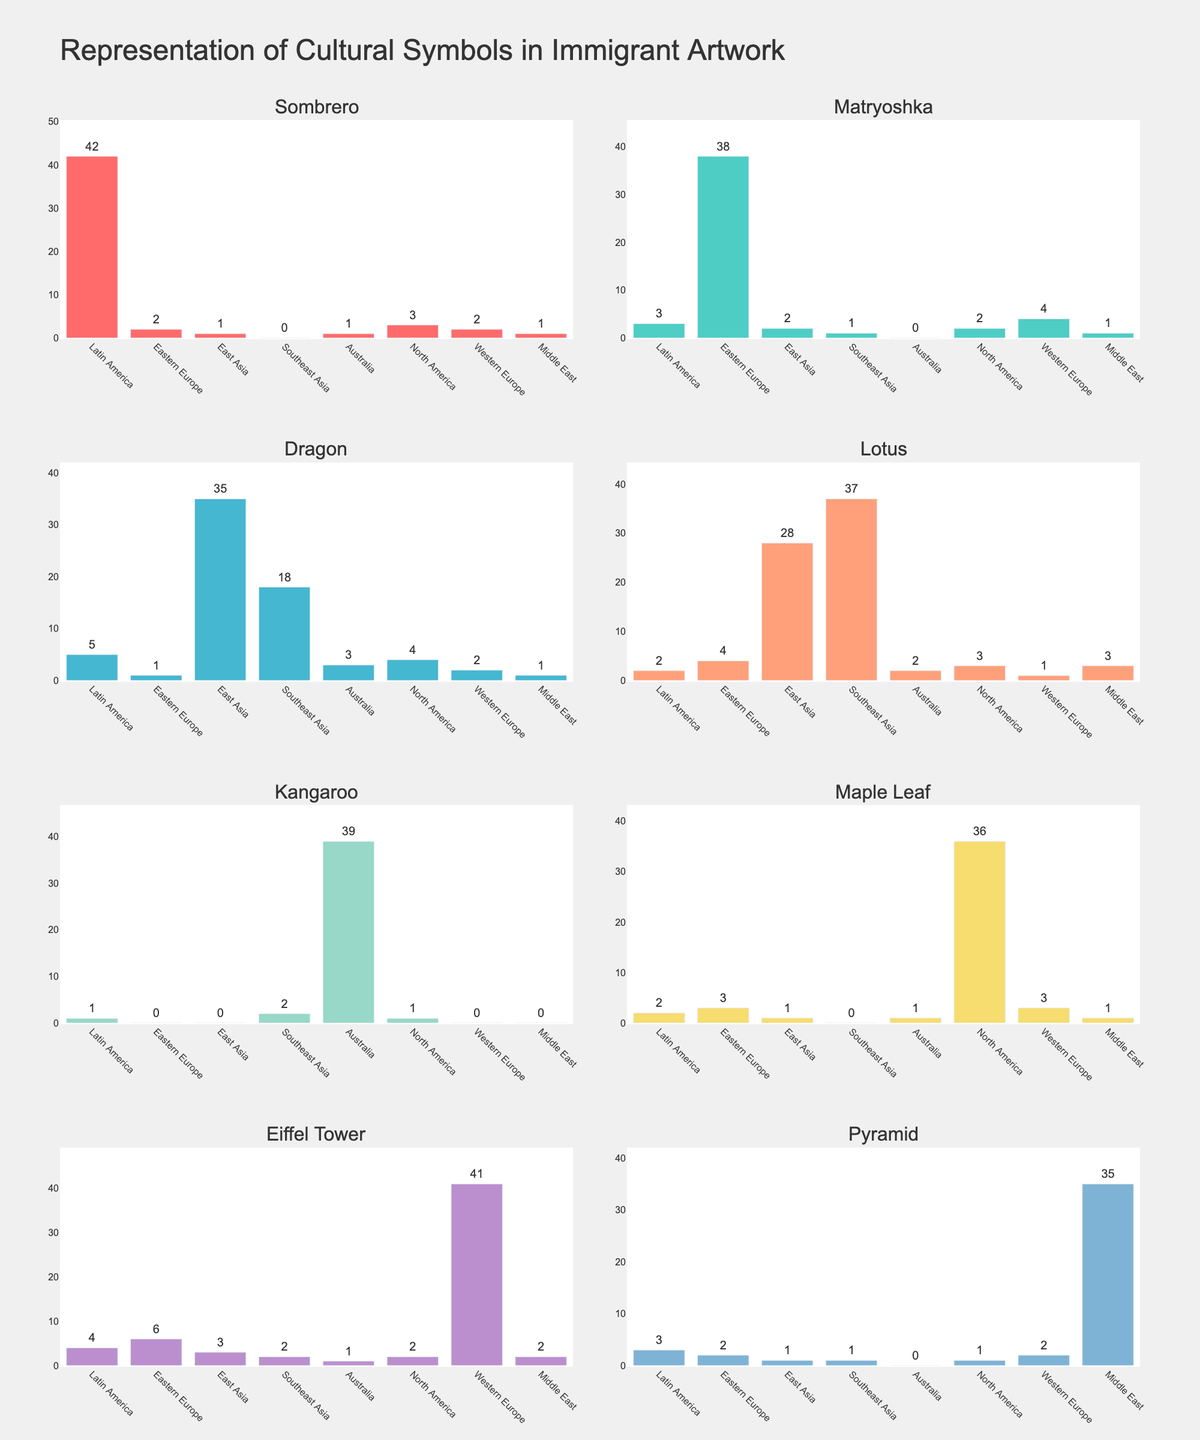What is the title of the figure? The title of the figure is located at the top of the entire plot and reads "Governor's Policy Approval Ratings (2020-2023)". The font is large and prominent, making it easy to identify.
Answer: Governor's Policy Approval Ratings (2020-2023) Which policy issue had the highest approval rating in 2023? Look for the 2023 data points on each subplot and identify the highest one. "Healthcare" has an approval rating of 70%.
Answer: Healthcare How did the approval rating for the Environment policy change from 2020 to 2023? Locate the Environment subplot and compare the points from 2020 (51%) to 2023 (60%). The approval rating increased by 9%.
Answer: Increased by 9% What is the general trend for the approval rating in the Education policy? Look at the Education subplot and observe the data points over the years. They show a consistent upward trend from 58% in 2020 to 65% in 2023.
Answer: Upward trend Which year had the lowest approval rating for the Economy policy? In the Economy subplot, identify the lowest point across all years. The lowest approval rating was in 2020 at 55%.
Answer: 2020 Calculate the average approval rating for Healthcare over the given years. Add the approval ratings for Healthcare (62, 65, 68, 70) and divide by the number of years (4). The calculation is (62+65+68+70)/4 = 66.25%.
Answer: 66.25% In which year did the approval rating for all policies increase compared to the previous year? Analyze each subplot and compare the year-to-year changes. All policies saw an increase from 2020 to 2021.
Answer: 2021 Which policy had the smallest increase in approval rating from 2020 to 2023? Calculate the increase for each policy: Healthcare (8%), Education (7%), Economy (9%), Environment (9%). Education had the smallest increase.
Answer: Education Were there any years when the approval rating for the Economy policy decreased? Review the Economy subplot for any downward slopes. There were no decreases; the approval rating increased every year.
Answer: No Which policy issue shows the most consistent increase in approval ratings over the years? Assess the trend lines in each subplot for consistency in upward movement with no decreases. "Healthcare" shows the most consistent increase.
Answer: Healthcare 